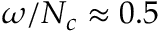Convert formula to latex. <formula><loc_0><loc_0><loc_500><loc_500>\omega / N _ { c } \approx 0 . 5</formula> 